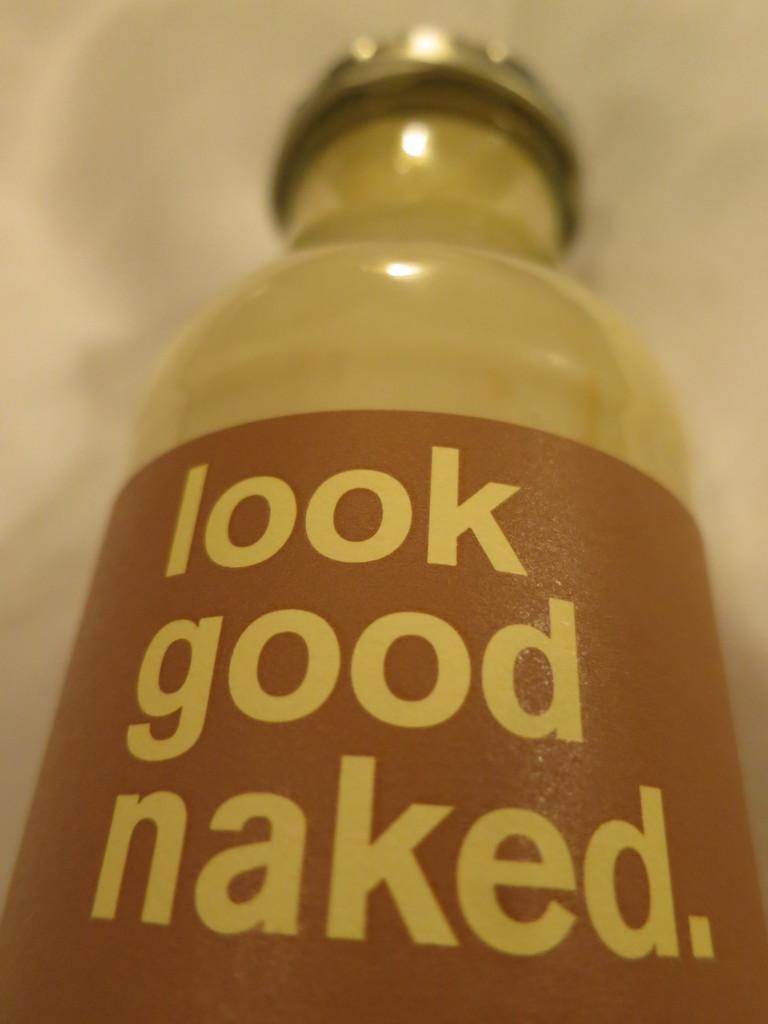In one or two sentences, can you explain what this image depicts? There is a bottle. The bottle has a sticker. The bottle has a cap. The bottle placed on a floor. 